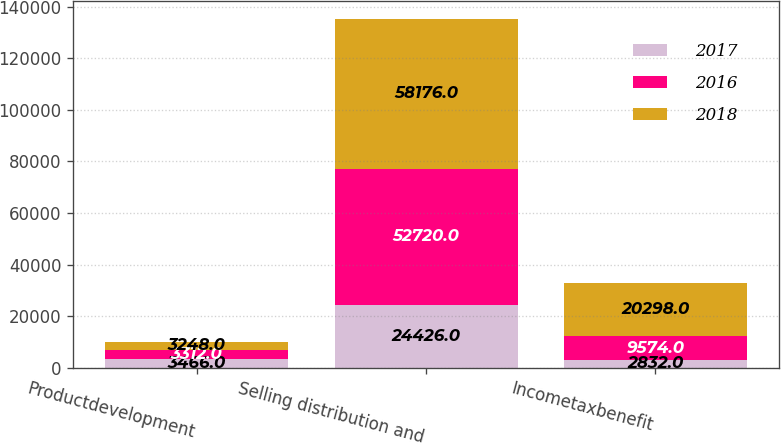<chart> <loc_0><loc_0><loc_500><loc_500><stacked_bar_chart><ecel><fcel>Productdevelopment<fcel>Selling distribution and<fcel>Incometaxbenefit<nl><fcel>2017<fcel>3466<fcel>24426<fcel>2832<nl><fcel>2016<fcel>3312<fcel>52720<fcel>9574<nl><fcel>2018<fcel>3248<fcel>58176<fcel>20298<nl></chart> 